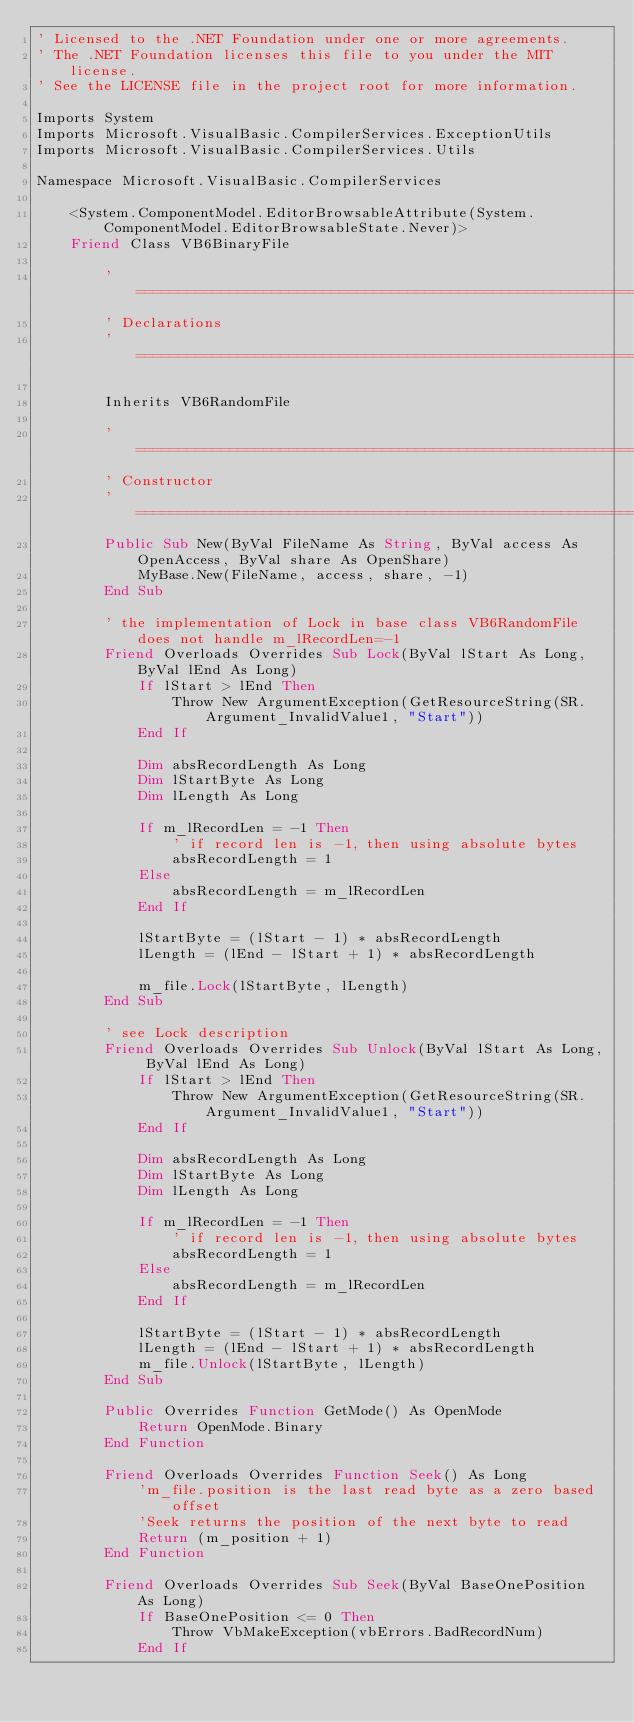Convert code to text. <code><loc_0><loc_0><loc_500><loc_500><_VisualBasic_>' Licensed to the .NET Foundation under one or more agreements.
' The .NET Foundation licenses this file to you under the MIT license.
' See the LICENSE file in the project root for more information.

Imports System
Imports Microsoft.VisualBasic.CompilerServices.ExceptionUtils
Imports Microsoft.VisualBasic.CompilerServices.Utils

Namespace Microsoft.VisualBasic.CompilerServices

    <System.ComponentModel.EditorBrowsableAttribute(System.ComponentModel.EditorBrowsableState.Never)>
    Friend Class VB6BinaryFile

        '============================================================================
        ' Declarations
        '============================================================================

        Inherits VB6RandomFile

        '============================================================================
        ' Constructor
        '============================================================================
        Public Sub New(ByVal FileName As String, ByVal access As OpenAccess, ByVal share As OpenShare)
            MyBase.New(FileName, access, share, -1)
        End Sub

        ' the implementation of Lock in base class VB6RandomFile does not handle m_lRecordLen=-1
        Friend Overloads Overrides Sub Lock(ByVal lStart As Long, ByVal lEnd As Long)
            If lStart > lEnd Then
                Throw New ArgumentException(GetResourceString(SR.Argument_InvalidValue1, "Start"))
            End If

            Dim absRecordLength As Long
            Dim lStartByte As Long
            Dim lLength As Long

            If m_lRecordLen = -1 Then
                ' if record len is -1, then using absolute bytes
                absRecordLength = 1
            Else
                absRecordLength = m_lRecordLen
            End If

            lStartByte = (lStart - 1) * absRecordLength
            lLength = (lEnd - lStart + 1) * absRecordLength

            m_file.Lock(lStartByte, lLength)
        End Sub

        ' see Lock description
        Friend Overloads Overrides Sub Unlock(ByVal lStart As Long, ByVal lEnd As Long)
            If lStart > lEnd Then
                Throw New ArgumentException(GetResourceString(SR.Argument_InvalidValue1, "Start"))
            End If

            Dim absRecordLength As Long
            Dim lStartByte As Long
            Dim lLength As Long

            If m_lRecordLen = -1 Then
                ' if record len is -1, then using absolute bytes
                absRecordLength = 1
            Else
                absRecordLength = m_lRecordLen
            End If

            lStartByte = (lStart - 1) * absRecordLength
            lLength = (lEnd - lStart + 1) * absRecordLength
            m_file.Unlock(lStartByte, lLength)
        End Sub

        Public Overrides Function GetMode() As OpenMode
            Return OpenMode.Binary
        End Function

        Friend Overloads Overrides Function Seek() As Long
            'm_file.position is the last read byte as a zero based offset
            'Seek returns the position of the next byte to read
            Return (m_position + 1)
        End Function

        Friend Overloads Overrides Sub Seek(ByVal BaseOnePosition As Long)
            If BaseOnePosition <= 0 Then
                Throw VbMakeException(vbErrors.BadRecordNum)
            End If
</code> 